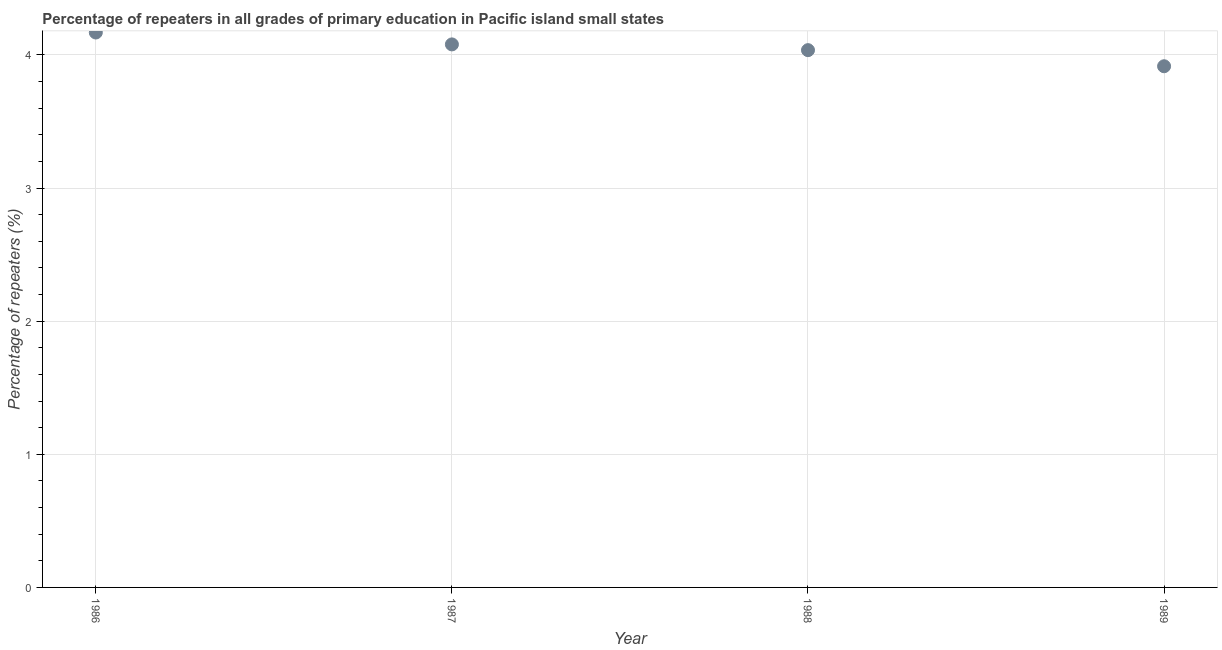What is the percentage of repeaters in primary education in 1987?
Offer a very short reply. 4.08. Across all years, what is the maximum percentage of repeaters in primary education?
Keep it short and to the point. 4.17. Across all years, what is the minimum percentage of repeaters in primary education?
Provide a short and direct response. 3.92. In which year was the percentage of repeaters in primary education minimum?
Your answer should be compact. 1989. What is the sum of the percentage of repeaters in primary education?
Your answer should be very brief. 16.2. What is the difference between the percentage of repeaters in primary education in 1986 and 1989?
Provide a short and direct response. 0.25. What is the average percentage of repeaters in primary education per year?
Provide a succinct answer. 4.05. What is the median percentage of repeaters in primary education?
Your answer should be very brief. 4.06. Do a majority of the years between 1986 and 1988 (inclusive) have percentage of repeaters in primary education greater than 0.6000000000000001 %?
Make the answer very short. Yes. What is the ratio of the percentage of repeaters in primary education in 1986 to that in 1987?
Your answer should be compact. 1.02. Is the percentage of repeaters in primary education in 1986 less than that in 1987?
Make the answer very short. No. What is the difference between the highest and the second highest percentage of repeaters in primary education?
Provide a succinct answer. 0.09. Is the sum of the percentage of repeaters in primary education in 1986 and 1987 greater than the maximum percentage of repeaters in primary education across all years?
Make the answer very short. Yes. What is the difference between the highest and the lowest percentage of repeaters in primary education?
Your response must be concise. 0.25. Does the percentage of repeaters in primary education monotonically increase over the years?
Your answer should be compact. No. How many dotlines are there?
Your answer should be compact. 1. How many years are there in the graph?
Your answer should be very brief. 4. Does the graph contain any zero values?
Offer a terse response. No. Does the graph contain grids?
Your response must be concise. Yes. What is the title of the graph?
Ensure brevity in your answer.  Percentage of repeaters in all grades of primary education in Pacific island small states. What is the label or title of the Y-axis?
Provide a short and direct response. Percentage of repeaters (%). What is the Percentage of repeaters (%) in 1986?
Make the answer very short. 4.17. What is the Percentage of repeaters (%) in 1987?
Offer a very short reply. 4.08. What is the Percentage of repeaters (%) in 1988?
Offer a terse response. 4.04. What is the Percentage of repeaters (%) in 1989?
Ensure brevity in your answer.  3.92. What is the difference between the Percentage of repeaters (%) in 1986 and 1987?
Offer a very short reply. 0.09. What is the difference between the Percentage of repeaters (%) in 1986 and 1988?
Your response must be concise. 0.13. What is the difference between the Percentage of repeaters (%) in 1986 and 1989?
Offer a very short reply. 0.25. What is the difference between the Percentage of repeaters (%) in 1987 and 1988?
Provide a succinct answer. 0.04. What is the difference between the Percentage of repeaters (%) in 1987 and 1989?
Your response must be concise. 0.16. What is the difference between the Percentage of repeaters (%) in 1988 and 1989?
Offer a terse response. 0.12. What is the ratio of the Percentage of repeaters (%) in 1986 to that in 1988?
Provide a succinct answer. 1.03. What is the ratio of the Percentage of repeaters (%) in 1986 to that in 1989?
Make the answer very short. 1.06. What is the ratio of the Percentage of repeaters (%) in 1987 to that in 1988?
Your answer should be compact. 1.01. What is the ratio of the Percentage of repeaters (%) in 1987 to that in 1989?
Give a very brief answer. 1.04. What is the ratio of the Percentage of repeaters (%) in 1988 to that in 1989?
Your answer should be compact. 1.03. 